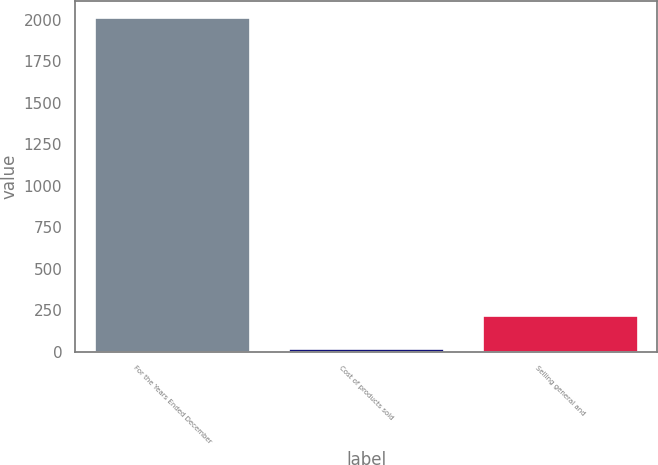<chart> <loc_0><loc_0><loc_500><loc_500><bar_chart><fcel>For the Years Ended December<fcel>Cost of products sold<fcel>Selling general and<nl><fcel>2013<fcel>18.3<fcel>217.77<nl></chart> 